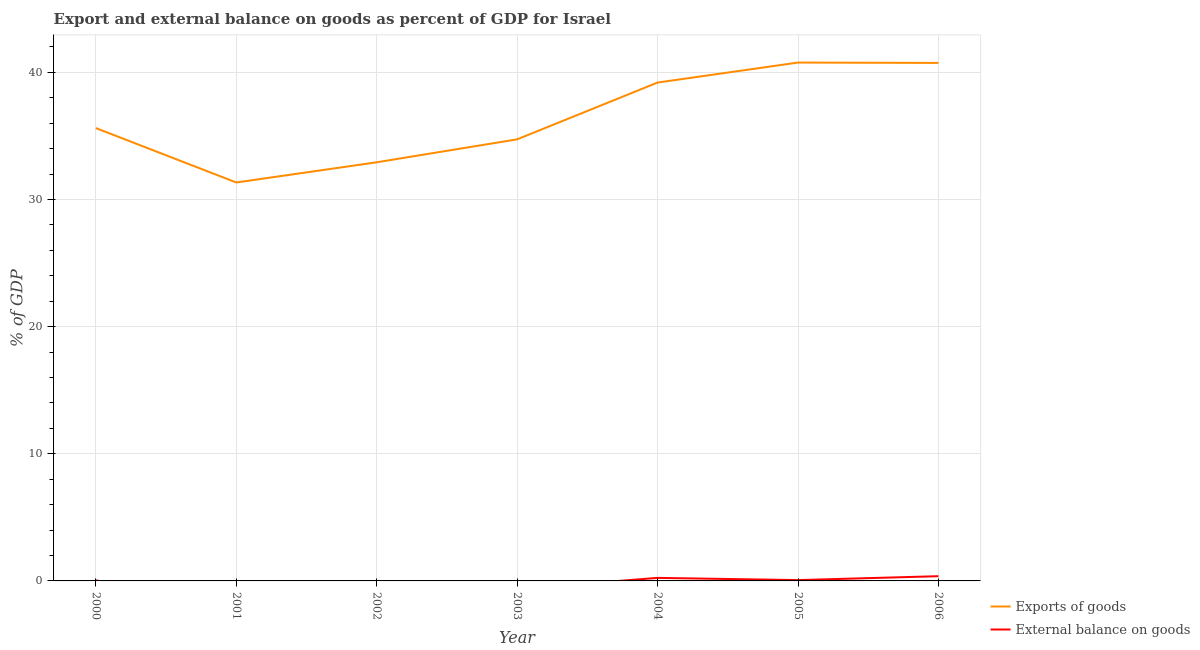How many different coloured lines are there?
Your answer should be very brief. 2. Is the number of lines equal to the number of legend labels?
Ensure brevity in your answer.  No. Across all years, what is the maximum external balance on goods as percentage of gdp?
Your answer should be very brief. 0.37. Across all years, what is the minimum export of goods as percentage of gdp?
Your response must be concise. 31.34. What is the total export of goods as percentage of gdp in the graph?
Provide a short and direct response. 255.33. What is the difference between the export of goods as percentage of gdp in 2000 and that in 2002?
Make the answer very short. 2.69. What is the difference between the export of goods as percentage of gdp in 2005 and the external balance on goods as percentage of gdp in 2001?
Provide a succinct answer. 40.77. What is the average external balance on goods as percentage of gdp per year?
Offer a terse response. 0.1. In the year 2004, what is the difference between the export of goods as percentage of gdp and external balance on goods as percentage of gdp?
Ensure brevity in your answer.  38.96. In how many years, is the external balance on goods as percentage of gdp greater than 20 %?
Your response must be concise. 0. What is the ratio of the export of goods as percentage of gdp in 2002 to that in 2005?
Your answer should be very brief. 0.81. Is the export of goods as percentage of gdp in 2000 less than that in 2005?
Your answer should be very brief. Yes. What is the difference between the highest and the second highest external balance on goods as percentage of gdp?
Your response must be concise. 0.13. What is the difference between the highest and the lowest external balance on goods as percentage of gdp?
Your answer should be very brief. 0.37. Is the external balance on goods as percentage of gdp strictly less than the export of goods as percentage of gdp over the years?
Ensure brevity in your answer.  Yes. How many years are there in the graph?
Your answer should be compact. 7. Does the graph contain any zero values?
Make the answer very short. Yes. Does the graph contain grids?
Your answer should be compact. Yes. Where does the legend appear in the graph?
Ensure brevity in your answer.  Bottom right. How many legend labels are there?
Your response must be concise. 2. How are the legend labels stacked?
Your response must be concise. Vertical. What is the title of the graph?
Make the answer very short. Export and external balance on goods as percent of GDP for Israel. Does "Girls" appear as one of the legend labels in the graph?
Offer a terse response. No. What is the label or title of the X-axis?
Keep it short and to the point. Year. What is the label or title of the Y-axis?
Give a very brief answer. % of GDP. What is the % of GDP in Exports of goods in 2000?
Provide a short and direct response. 35.62. What is the % of GDP of External balance on goods in 2000?
Make the answer very short. 0.05. What is the % of GDP of Exports of goods in 2001?
Ensure brevity in your answer.  31.34. What is the % of GDP in External balance on goods in 2001?
Make the answer very short. 0. What is the % of GDP in Exports of goods in 2002?
Offer a terse response. 32.93. What is the % of GDP in External balance on goods in 2002?
Your answer should be compact. 0. What is the % of GDP of Exports of goods in 2003?
Give a very brief answer. 34.73. What is the % of GDP in Exports of goods in 2004?
Make the answer very short. 39.2. What is the % of GDP in External balance on goods in 2004?
Give a very brief answer. 0.24. What is the % of GDP of Exports of goods in 2005?
Ensure brevity in your answer.  40.77. What is the % of GDP of External balance on goods in 2005?
Make the answer very short. 0.06. What is the % of GDP of Exports of goods in 2006?
Provide a succinct answer. 40.74. What is the % of GDP in External balance on goods in 2006?
Give a very brief answer. 0.37. Across all years, what is the maximum % of GDP of Exports of goods?
Your answer should be compact. 40.77. Across all years, what is the maximum % of GDP of External balance on goods?
Your answer should be compact. 0.37. Across all years, what is the minimum % of GDP in Exports of goods?
Your answer should be compact. 31.34. Across all years, what is the minimum % of GDP of External balance on goods?
Keep it short and to the point. 0. What is the total % of GDP in Exports of goods in the graph?
Your answer should be compact. 255.33. What is the total % of GDP in External balance on goods in the graph?
Your response must be concise. 0.72. What is the difference between the % of GDP in Exports of goods in 2000 and that in 2001?
Your response must be concise. 4.28. What is the difference between the % of GDP in Exports of goods in 2000 and that in 2002?
Ensure brevity in your answer.  2.69. What is the difference between the % of GDP of Exports of goods in 2000 and that in 2003?
Offer a very short reply. 0.89. What is the difference between the % of GDP of Exports of goods in 2000 and that in 2004?
Your answer should be compact. -3.58. What is the difference between the % of GDP in External balance on goods in 2000 and that in 2004?
Provide a short and direct response. -0.19. What is the difference between the % of GDP in Exports of goods in 2000 and that in 2005?
Offer a terse response. -5.15. What is the difference between the % of GDP of External balance on goods in 2000 and that in 2005?
Your answer should be very brief. -0.02. What is the difference between the % of GDP in Exports of goods in 2000 and that in 2006?
Your response must be concise. -5.13. What is the difference between the % of GDP in External balance on goods in 2000 and that in 2006?
Provide a succinct answer. -0.33. What is the difference between the % of GDP of Exports of goods in 2001 and that in 2002?
Your answer should be very brief. -1.59. What is the difference between the % of GDP of Exports of goods in 2001 and that in 2003?
Your answer should be very brief. -3.39. What is the difference between the % of GDP in Exports of goods in 2001 and that in 2004?
Ensure brevity in your answer.  -7.86. What is the difference between the % of GDP in Exports of goods in 2001 and that in 2005?
Your response must be concise. -9.43. What is the difference between the % of GDP of Exports of goods in 2001 and that in 2006?
Keep it short and to the point. -9.4. What is the difference between the % of GDP in Exports of goods in 2002 and that in 2003?
Your answer should be very brief. -1.81. What is the difference between the % of GDP in Exports of goods in 2002 and that in 2004?
Provide a short and direct response. -6.27. What is the difference between the % of GDP in Exports of goods in 2002 and that in 2005?
Offer a terse response. -7.84. What is the difference between the % of GDP in Exports of goods in 2002 and that in 2006?
Give a very brief answer. -7.82. What is the difference between the % of GDP of Exports of goods in 2003 and that in 2004?
Give a very brief answer. -4.47. What is the difference between the % of GDP in Exports of goods in 2003 and that in 2005?
Give a very brief answer. -6.04. What is the difference between the % of GDP in Exports of goods in 2003 and that in 2006?
Your answer should be compact. -6.01. What is the difference between the % of GDP of Exports of goods in 2004 and that in 2005?
Make the answer very short. -1.57. What is the difference between the % of GDP in External balance on goods in 2004 and that in 2005?
Keep it short and to the point. 0.17. What is the difference between the % of GDP in Exports of goods in 2004 and that in 2006?
Make the answer very short. -1.54. What is the difference between the % of GDP in External balance on goods in 2004 and that in 2006?
Offer a terse response. -0.13. What is the difference between the % of GDP in Exports of goods in 2005 and that in 2006?
Provide a succinct answer. 0.03. What is the difference between the % of GDP in External balance on goods in 2005 and that in 2006?
Your answer should be compact. -0.31. What is the difference between the % of GDP of Exports of goods in 2000 and the % of GDP of External balance on goods in 2004?
Provide a succinct answer. 35.38. What is the difference between the % of GDP of Exports of goods in 2000 and the % of GDP of External balance on goods in 2005?
Offer a terse response. 35.55. What is the difference between the % of GDP of Exports of goods in 2000 and the % of GDP of External balance on goods in 2006?
Offer a terse response. 35.24. What is the difference between the % of GDP in Exports of goods in 2001 and the % of GDP in External balance on goods in 2004?
Offer a very short reply. 31.1. What is the difference between the % of GDP of Exports of goods in 2001 and the % of GDP of External balance on goods in 2005?
Give a very brief answer. 31.27. What is the difference between the % of GDP of Exports of goods in 2001 and the % of GDP of External balance on goods in 2006?
Provide a succinct answer. 30.97. What is the difference between the % of GDP in Exports of goods in 2002 and the % of GDP in External balance on goods in 2004?
Give a very brief answer. 32.69. What is the difference between the % of GDP in Exports of goods in 2002 and the % of GDP in External balance on goods in 2005?
Your answer should be very brief. 32.86. What is the difference between the % of GDP of Exports of goods in 2002 and the % of GDP of External balance on goods in 2006?
Make the answer very short. 32.55. What is the difference between the % of GDP in Exports of goods in 2003 and the % of GDP in External balance on goods in 2004?
Your answer should be very brief. 34.49. What is the difference between the % of GDP in Exports of goods in 2003 and the % of GDP in External balance on goods in 2005?
Offer a very short reply. 34.67. What is the difference between the % of GDP of Exports of goods in 2003 and the % of GDP of External balance on goods in 2006?
Your answer should be very brief. 34.36. What is the difference between the % of GDP in Exports of goods in 2004 and the % of GDP in External balance on goods in 2005?
Your response must be concise. 39.13. What is the difference between the % of GDP in Exports of goods in 2004 and the % of GDP in External balance on goods in 2006?
Offer a very short reply. 38.83. What is the difference between the % of GDP of Exports of goods in 2005 and the % of GDP of External balance on goods in 2006?
Ensure brevity in your answer.  40.4. What is the average % of GDP of Exports of goods per year?
Give a very brief answer. 36.48. What is the average % of GDP in External balance on goods per year?
Offer a very short reply. 0.1. In the year 2000, what is the difference between the % of GDP in Exports of goods and % of GDP in External balance on goods?
Provide a short and direct response. 35.57. In the year 2004, what is the difference between the % of GDP of Exports of goods and % of GDP of External balance on goods?
Provide a short and direct response. 38.96. In the year 2005, what is the difference between the % of GDP of Exports of goods and % of GDP of External balance on goods?
Keep it short and to the point. 40.71. In the year 2006, what is the difference between the % of GDP of Exports of goods and % of GDP of External balance on goods?
Offer a terse response. 40.37. What is the ratio of the % of GDP of Exports of goods in 2000 to that in 2001?
Keep it short and to the point. 1.14. What is the ratio of the % of GDP in Exports of goods in 2000 to that in 2002?
Your answer should be very brief. 1.08. What is the ratio of the % of GDP of Exports of goods in 2000 to that in 2003?
Make the answer very short. 1.03. What is the ratio of the % of GDP of Exports of goods in 2000 to that in 2004?
Your answer should be very brief. 0.91. What is the ratio of the % of GDP in External balance on goods in 2000 to that in 2004?
Offer a terse response. 0.2. What is the ratio of the % of GDP in Exports of goods in 2000 to that in 2005?
Provide a succinct answer. 0.87. What is the ratio of the % of GDP in External balance on goods in 2000 to that in 2005?
Your answer should be compact. 0.72. What is the ratio of the % of GDP in Exports of goods in 2000 to that in 2006?
Keep it short and to the point. 0.87. What is the ratio of the % of GDP in External balance on goods in 2000 to that in 2006?
Ensure brevity in your answer.  0.12. What is the ratio of the % of GDP in Exports of goods in 2001 to that in 2002?
Keep it short and to the point. 0.95. What is the ratio of the % of GDP of Exports of goods in 2001 to that in 2003?
Your response must be concise. 0.9. What is the ratio of the % of GDP of Exports of goods in 2001 to that in 2004?
Ensure brevity in your answer.  0.8. What is the ratio of the % of GDP in Exports of goods in 2001 to that in 2005?
Keep it short and to the point. 0.77. What is the ratio of the % of GDP in Exports of goods in 2001 to that in 2006?
Keep it short and to the point. 0.77. What is the ratio of the % of GDP of Exports of goods in 2002 to that in 2003?
Provide a short and direct response. 0.95. What is the ratio of the % of GDP in Exports of goods in 2002 to that in 2004?
Give a very brief answer. 0.84. What is the ratio of the % of GDP in Exports of goods in 2002 to that in 2005?
Your answer should be very brief. 0.81. What is the ratio of the % of GDP of Exports of goods in 2002 to that in 2006?
Provide a short and direct response. 0.81. What is the ratio of the % of GDP in Exports of goods in 2003 to that in 2004?
Keep it short and to the point. 0.89. What is the ratio of the % of GDP in Exports of goods in 2003 to that in 2005?
Keep it short and to the point. 0.85. What is the ratio of the % of GDP in Exports of goods in 2003 to that in 2006?
Give a very brief answer. 0.85. What is the ratio of the % of GDP of Exports of goods in 2004 to that in 2005?
Your answer should be very brief. 0.96. What is the ratio of the % of GDP of External balance on goods in 2004 to that in 2005?
Offer a very short reply. 3.69. What is the ratio of the % of GDP in Exports of goods in 2004 to that in 2006?
Offer a terse response. 0.96. What is the ratio of the % of GDP in External balance on goods in 2004 to that in 2006?
Ensure brevity in your answer.  0.64. What is the ratio of the % of GDP of External balance on goods in 2005 to that in 2006?
Ensure brevity in your answer.  0.17. What is the difference between the highest and the second highest % of GDP in Exports of goods?
Provide a short and direct response. 0.03. What is the difference between the highest and the second highest % of GDP of External balance on goods?
Keep it short and to the point. 0.13. What is the difference between the highest and the lowest % of GDP in Exports of goods?
Your answer should be compact. 9.43. What is the difference between the highest and the lowest % of GDP in External balance on goods?
Offer a terse response. 0.37. 